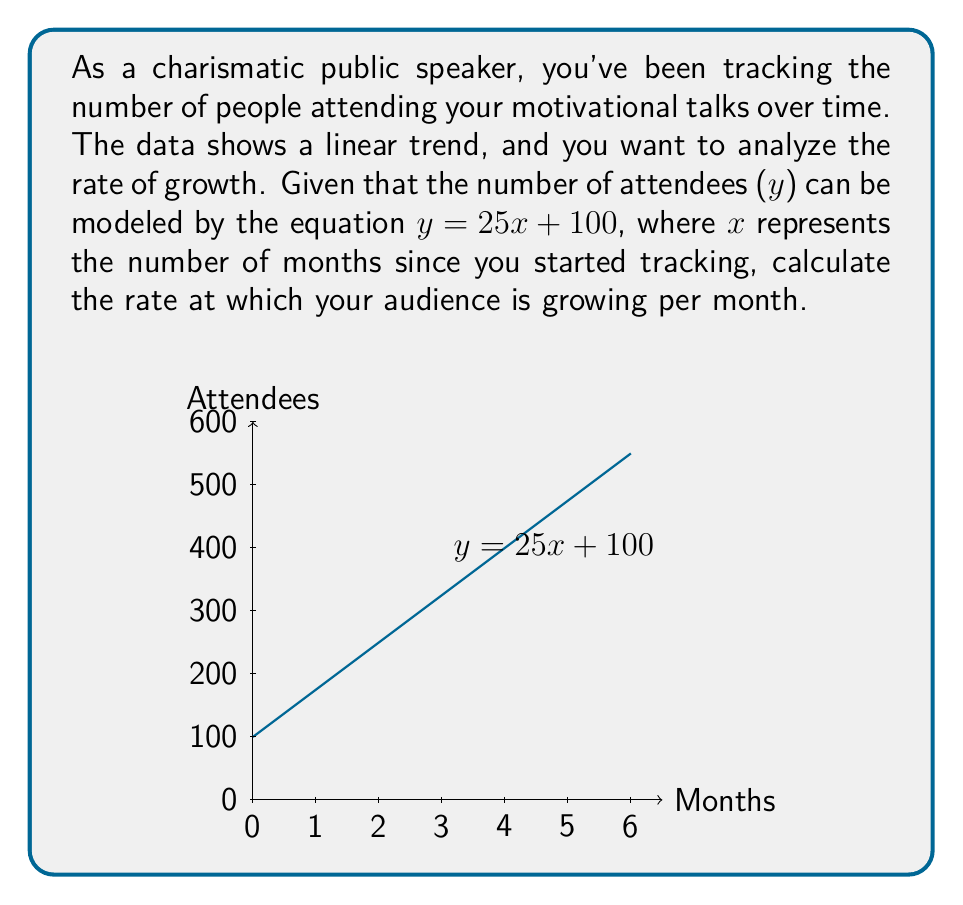Can you answer this question? To find the rate at which the audience is growing per month, we need to analyze the slope of the trend line. The given equation is in the form of a linear function:

$y = mx + b$

Where:
- $m$ is the slope (rate of change)
- $b$ is the y-intercept

In our case, we have:

$y = 25x + 100$

Comparing this to the standard form, we can see that:
- $m = 25$
- $b = 100$

The slope $m$ represents the rate of change of $y$ with respect to $x$. In other words, it tells us how much $y$ changes for each unit increase in $x$.

Since $x$ represents months and $y$ represents the number of attendees, the slope $m = 25$ indicates that the number of attendees is increasing by 25 per month.

To confirm this mathematically, we can use the definition of the derivative:

$$\frac{dy}{dx} = \lim_{h \to 0} \frac{f(x+h) - f(x)}{h}$$

For a linear function, this simplifies to:

$$\frac{dy}{dx} = 25$$

This derivative represents the instantaneous rate of change, which is constant for a linear function and equal to the slope.
Answer: 25 attendees per month 